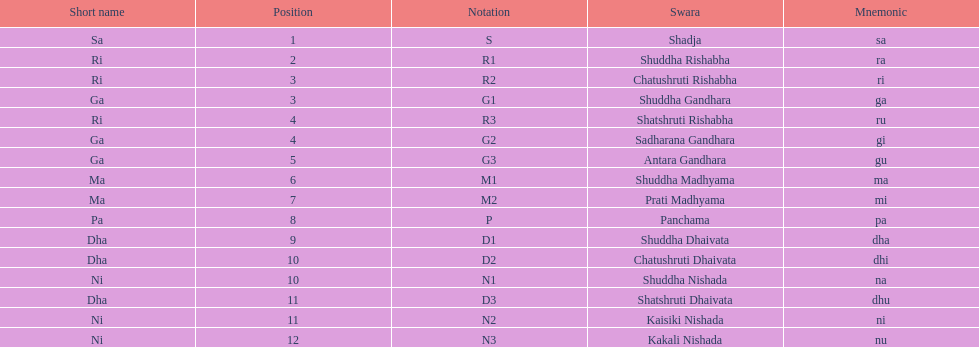What swara is above shatshruti dhaivata? Shuddha Nishada. 